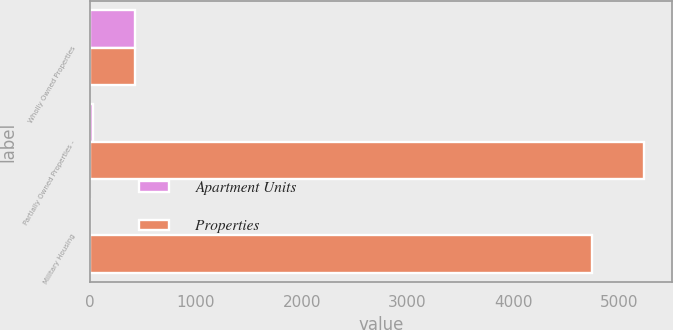Convert chart to OTSL. <chart><loc_0><loc_0><loc_500><loc_500><stacked_bar_chart><ecel><fcel>Wholly Owned Properties<fcel>Partially Owned Properties -<fcel>Military Housing<nl><fcel>Apartment Units<fcel>425<fcel>24<fcel>2<nl><fcel>Properties<fcel>425<fcel>5232<fcel>4738<nl></chart> 